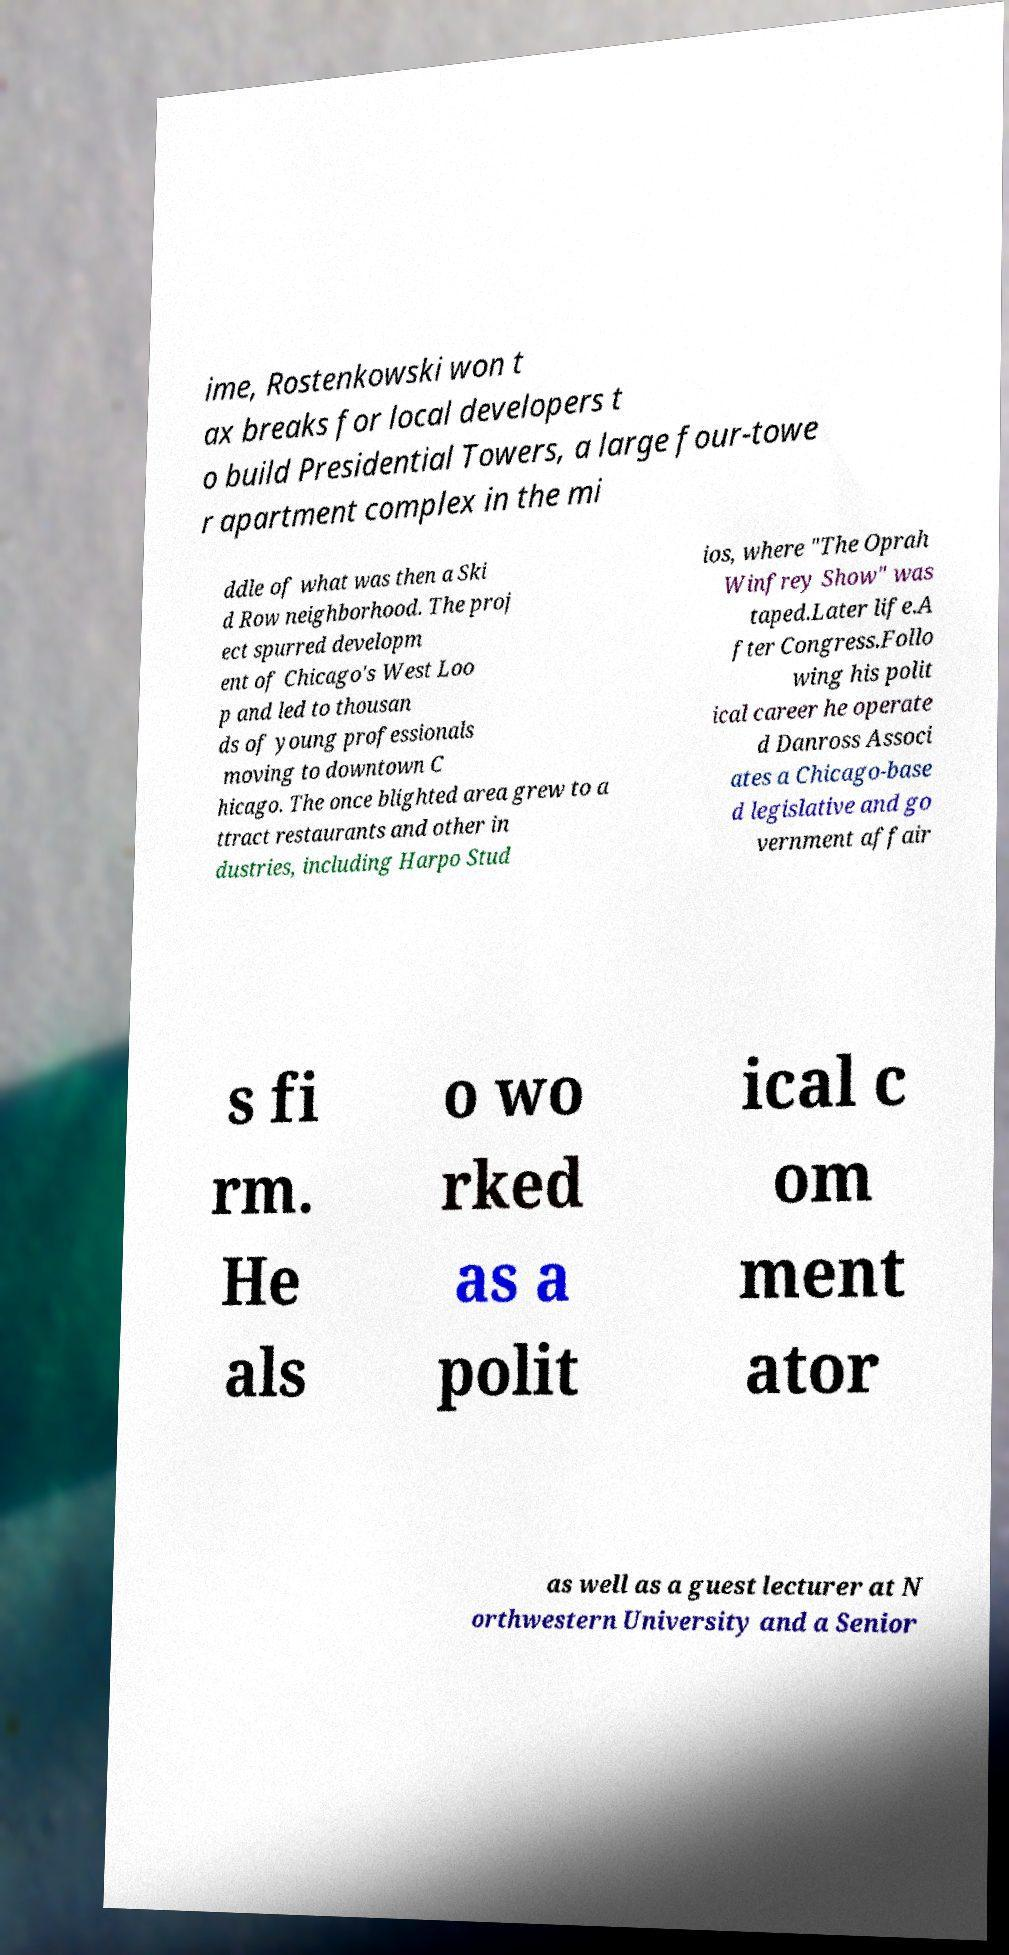Can you read and provide the text displayed in the image?This photo seems to have some interesting text. Can you extract and type it out for me? ime, Rostenkowski won t ax breaks for local developers t o build Presidential Towers, a large four-towe r apartment complex in the mi ddle of what was then a Ski d Row neighborhood. The proj ect spurred developm ent of Chicago's West Loo p and led to thousan ds of young professionals moving to downtown C hicago. The once blighted area grew to a ttract restaurants and other in dustries, including Harpo Stud ios, where "The Oprah Winfrey Show" was taped.Later life.A fter Congress.Follo wing his polit ical career he operate d Danross Associ ates a Chicago-base d legislative and go vernment affair s fi rm. He als o wo rked as a polit ical c om ment ator as well as a guest lecturer at N orthwestern University and a Senior 